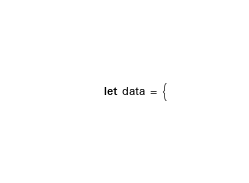Convert code to text. <code><loc_0><loc_0><loc_500><loc_500><_JavaScript_>let data = {</code> 